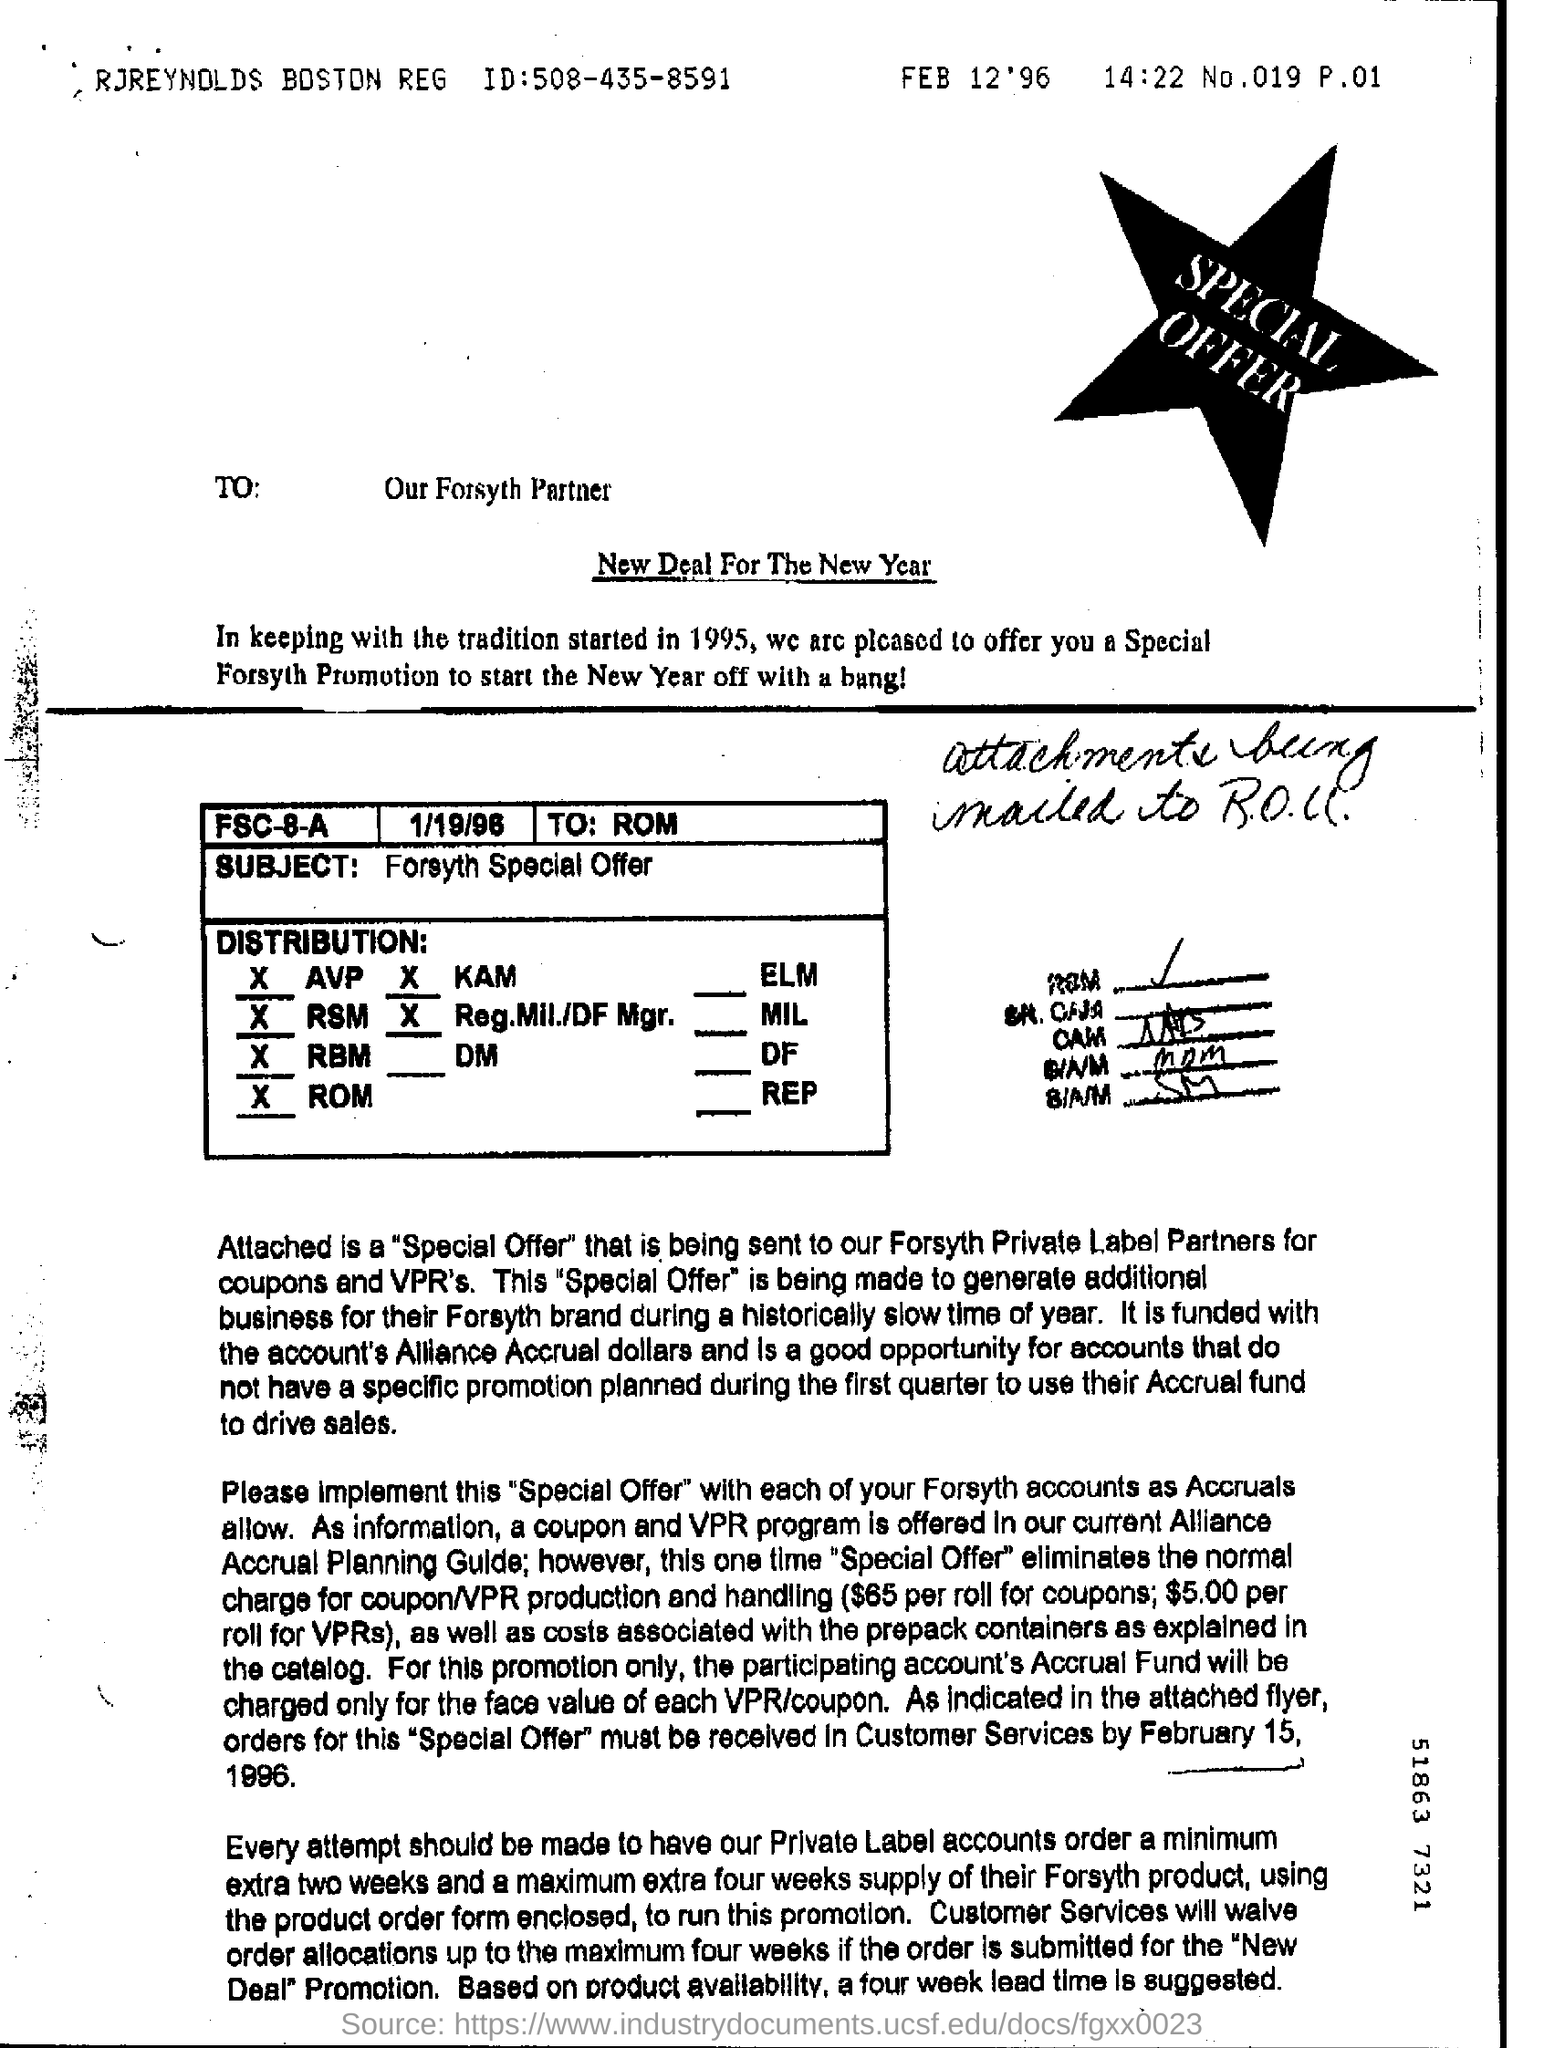Specify some key components in this picture. This document is addressed to Our Forsyth Partner. 